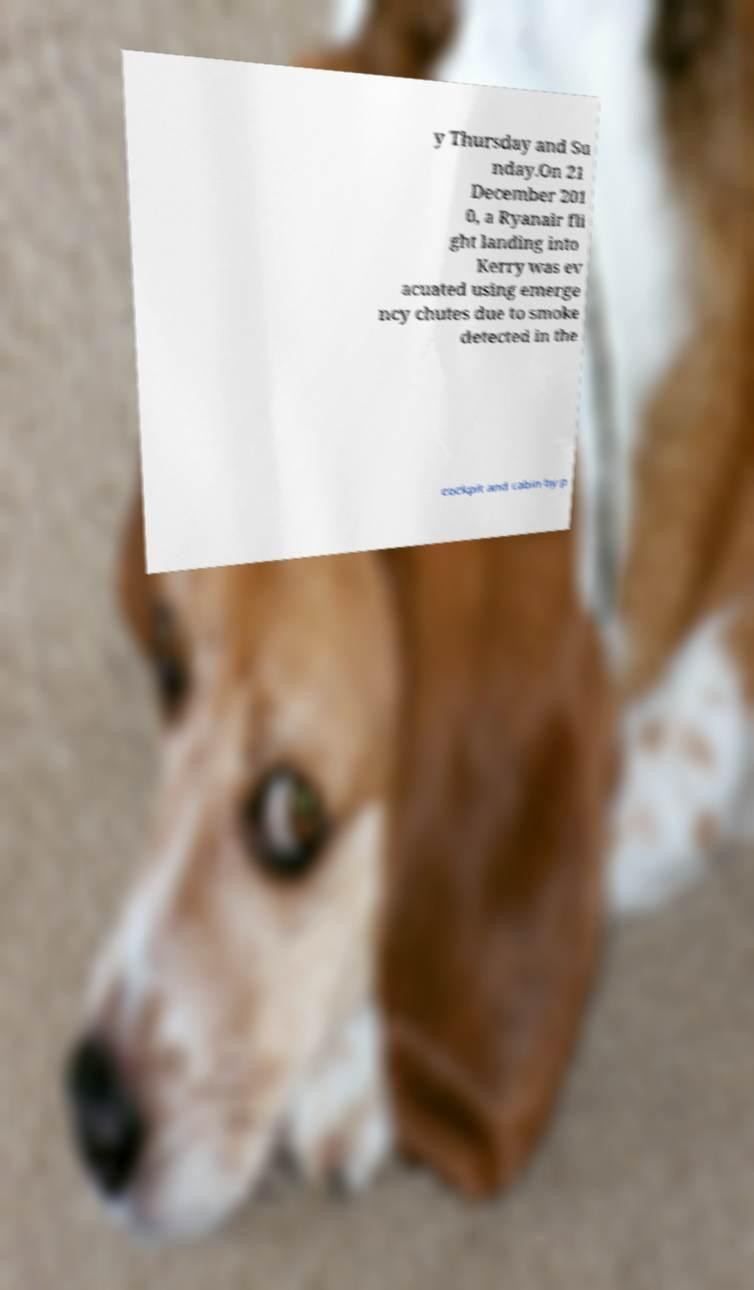Could you extract and type out the text from this image? y Thursday and Su nday.On 21 December 201 0, a Ryanair fli ght landing into Kerry was ev acuated using emerge ncy chutes due to smoke detected in the cockpit and cabin by p 